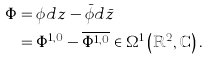<formula> <loc_0><loc_0><loc_500><loc_500>\Phi & = \phi d z - \bar { \phi } d \bar { z } \\ & = \Phi ^ { 1 , 0 } - \overline { \Phi ^ { 1 , 0 } } \in \Omega ^ { 1 } \left ( \mathbb { R } ^ { 2 } , \mathbb { C } \right ) .</formula> 